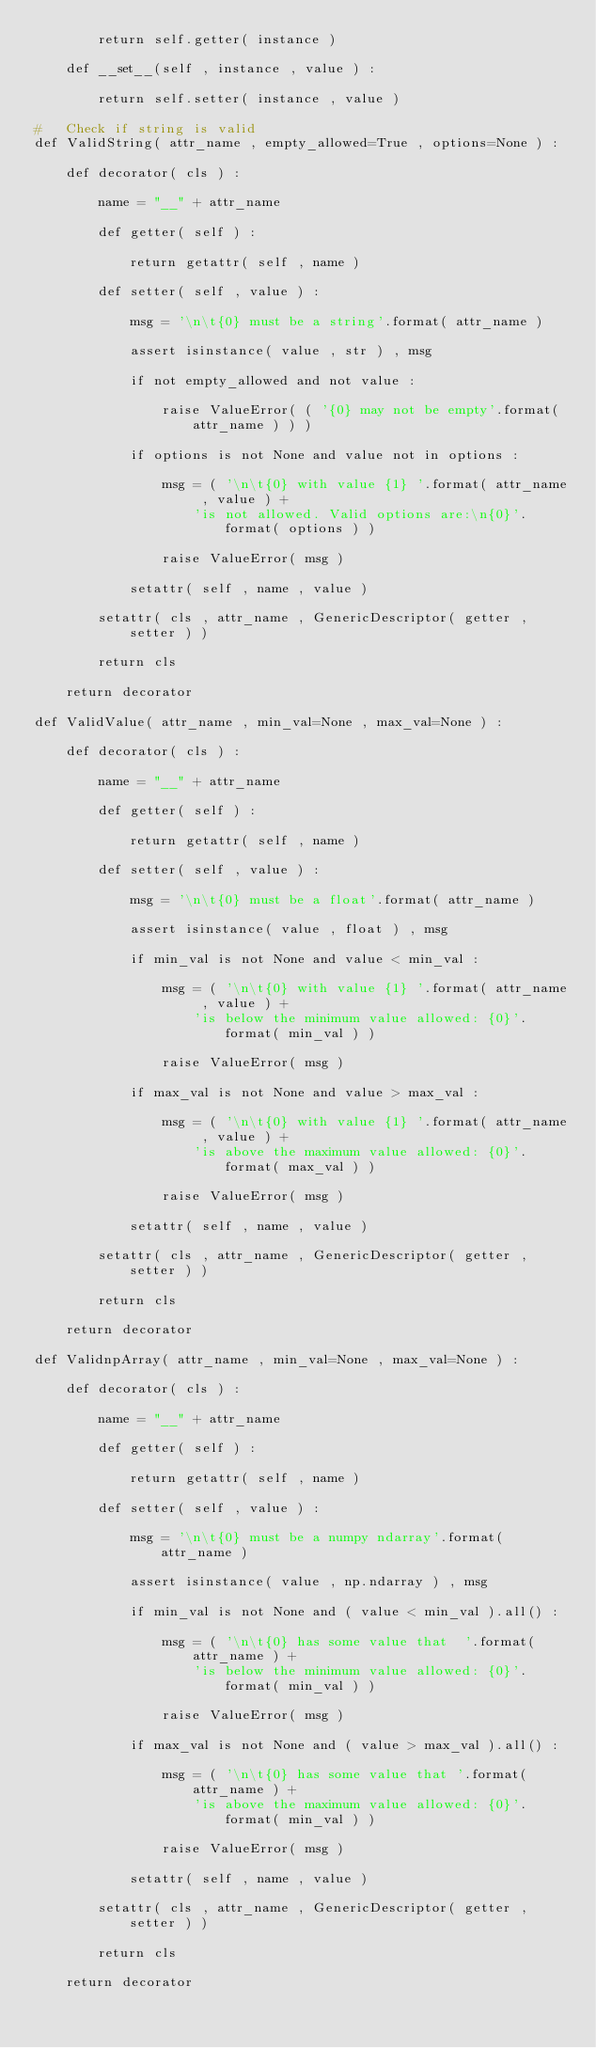Convert code to text. <code><loc_0><loc_0><loc_500><loc_500><_Python_>        return self.getter( instance )

    def __set__(self , instance , value ) :

        return self.setter( instance , value )

#   Check if string is valid
def ValidString( attr_name , empty_allowed=True , options=None ) :

    def decorator( cls ) :

        name = "__" + attr_name

        def getter( self ) :

            return getattr( self , name )

        def setter( self , value ) :

            msg = '\n\t{0} must be a string'.format( attr_name )

            assert isinstance( value , str ) , msg

            if not empty_allowed and not value :

                raise ValueError( ( '{0} may not be empty'.format( attr_name ) ) )

            if options is not None and value not in options :

                msg = ( '\n\t{0} with value {1} '.format( attr_name , value ) +
                    'is not allowed. Valid options are:\n{0}'.format( options ) )

                raise ValueError( msg )

            setattr( self , name , value )

        setattr( cls , attr_name , GenericDescriptor( getter , setter ) )

        return cls

    return decorator

def ValidValue( attr_name , min_val=None , max_val=None ) :

    def decorator( cls ) :

        name = "__" + attr_name

        def getter( self ) :

            return getattr( self , name )

        def setter( self , value ) :

            msg = '\n\t{0} must be a float'.format( attr_name )

            assert isinstance( value , float ) , msg

            if min_val is not None and value < min_val :

                msg = ( '\n\t{0} with value {1} '.format( attr_name , value ) +
                    'is below the minimum value allowed: {0}'.format( min_val ) )

                raise ValueError( msg )

            if max_val is not None and value > max_val :

                msg = ( '\n\t{0} with value {1} '.format( attr_name , value ) +
                    'is above the maximum value allowed: {0}'.format( max_val ) )

                raise ValueError( msg )

            setattr( self , name , value )

        setattr( cls , attr_name , GenericDescriptor( getter , setter ) )

        return cls

    return decorator

def ValidnpArray( attr_name , min_val=None , max_val=None ) :

    def decorator( cls ) :

        name = "__" + attr_name

        def getter( self ) :

            return getattr( self , name )

        def setter( self , value ) :

            msg = '\n\t{0} must be a numpy ndarray'.format( attr_name )

            assert isinstance( value , np.ndarray ) , msg

            if min_val is not None and ( value < min_val ).all() :

                msg = ( '\n\t{0} has some value that  '.format( attr_name ) +
                    'is below the minimum value allowed: {0}'.format( min_val ) )

                raise ValueError( msg )

            if max_val is not None and ( value > max_val ).all() :

                msg = ( '\n\t{0} has some value that '.format( attr_name ) +
                    'is above the maximum value allowed: {0}'.format( min_val ) )

                raise ValueError( msg )

            setattr( self , name , value )

        setattr( cls , attr_name , GenericDescriptor( getter , setter ) )

        return cls

    return decorator

</code> 